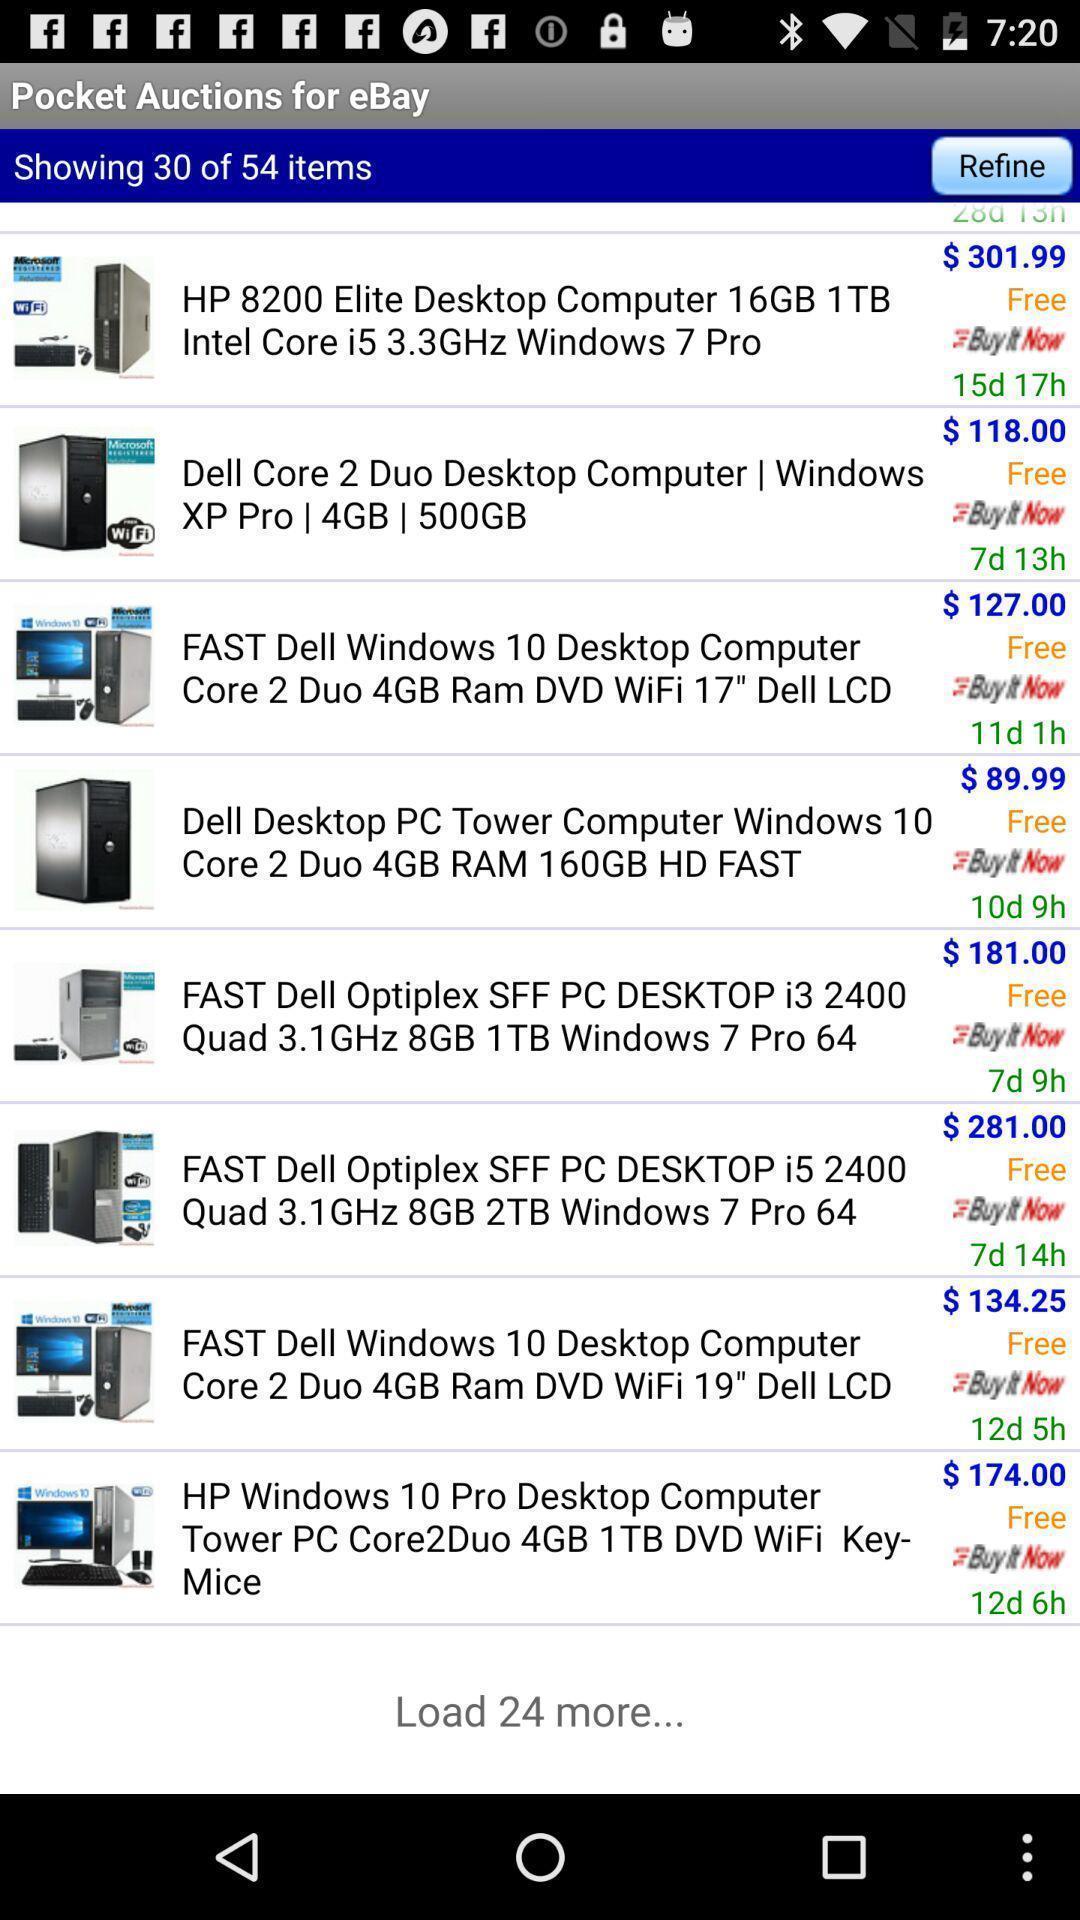Summarize the main components in this picture. Screen shows pocket auctions for ebay. 